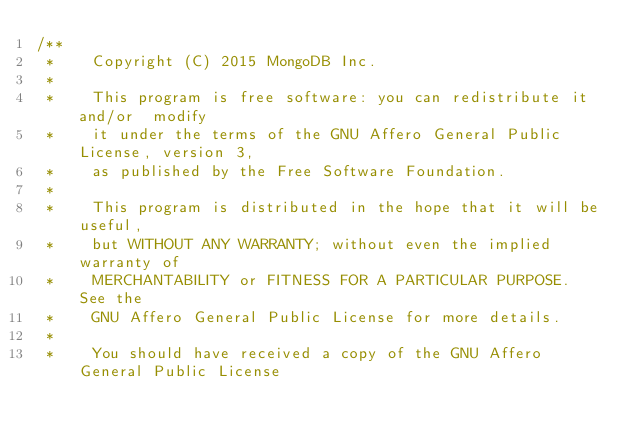Convert code to text. <code><loc_0><loc_0><loc_500><loc_500><_C++_>/**
 *    Copyright (C) 2015 MongoDB Inc.
 *
 *    This program is free software: you can redistribute it and/or  modify
 *    it under the terms of the GNU Affero General Public License, version 3,
 *    as published by the Free Software Foundation.
 *
 *    This program is distributed in the hope that it will be useful,
 *    but WITHOUT ANY WARRANTY; without even the implied warranty of
 *    MERCHANTABILITY or FITNESS FOR A PARTICULAR PURPOSE.  See the
 *    GNU Affero General Public License for more details.
 *
 *    You should have received a copy of the GNU Affero General Public License</code> 